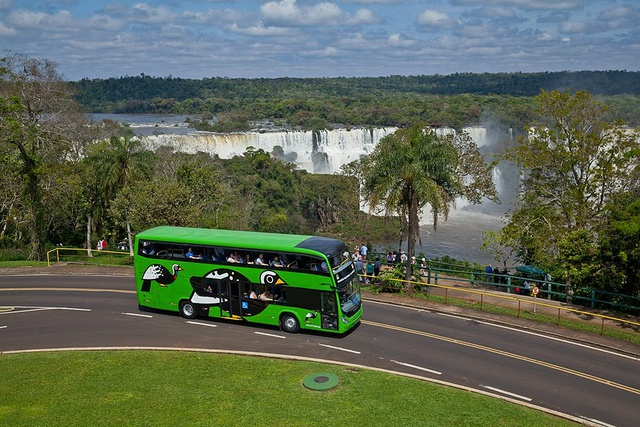Describe the objects in this image and their specific colors. I can see bus in darkgray, black, green, lightgreen, and gray tones, people in darkgray, black, gray, and darkgreen tones, people in darkgray, black, gray, and darkgreen tones, people in darkgray, black, teal, gray, and darkblue tones, and people in darkgray, black, gray, navy, and blue tones in this image. 